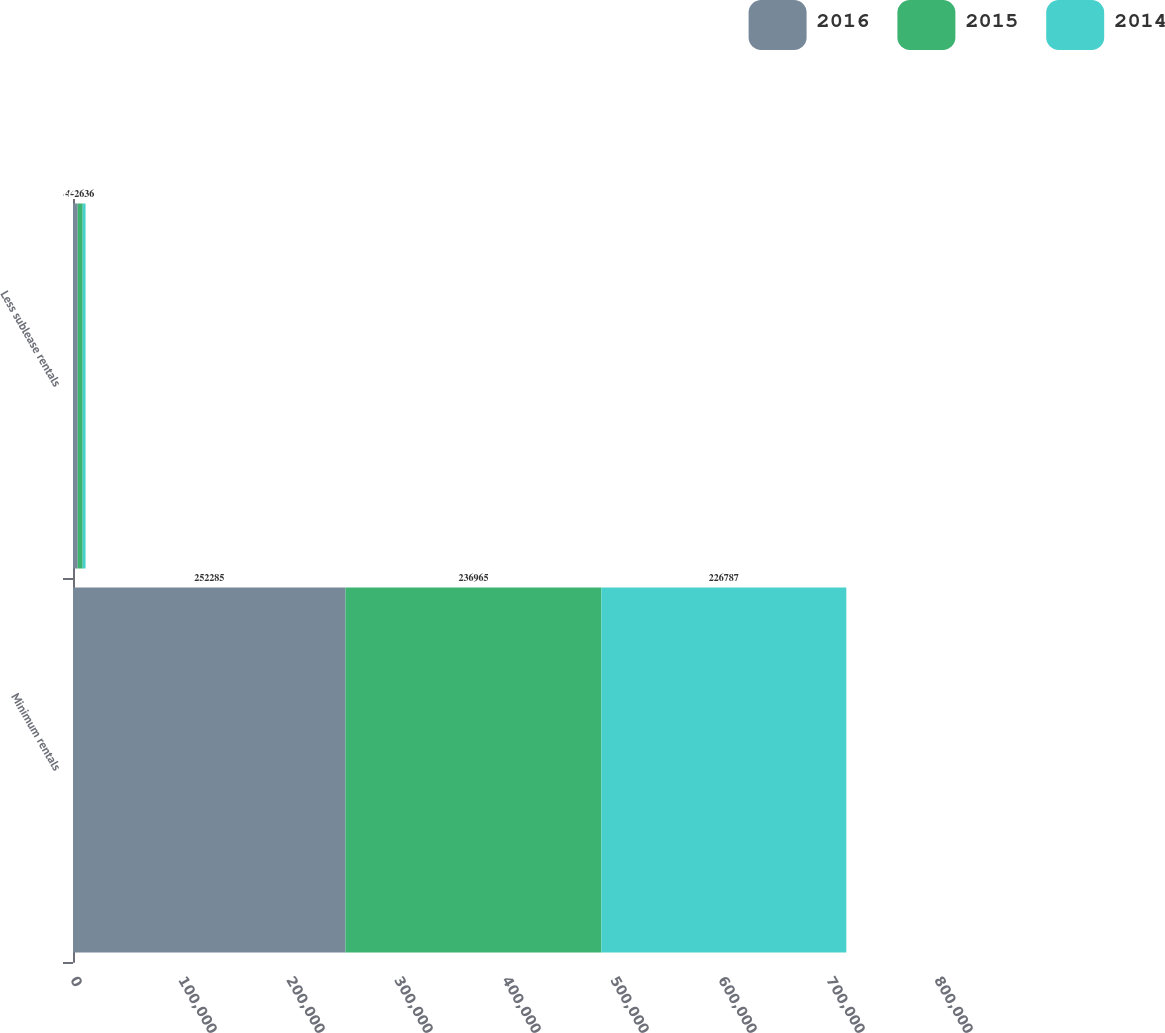<chart> <loc_0><loc_0><loc_500><loc_500><stacked_bar_chart><ecel><fcel>Minimum rentals<fcel>Less sublease rentals<nl><fcel>2016<fcel>252285<fcel>4322<nl><fcel>2015<fcel>236965<fcel>4673<nl><fcel>2014<fcel>226787<fcel>2636<nl></chart> 